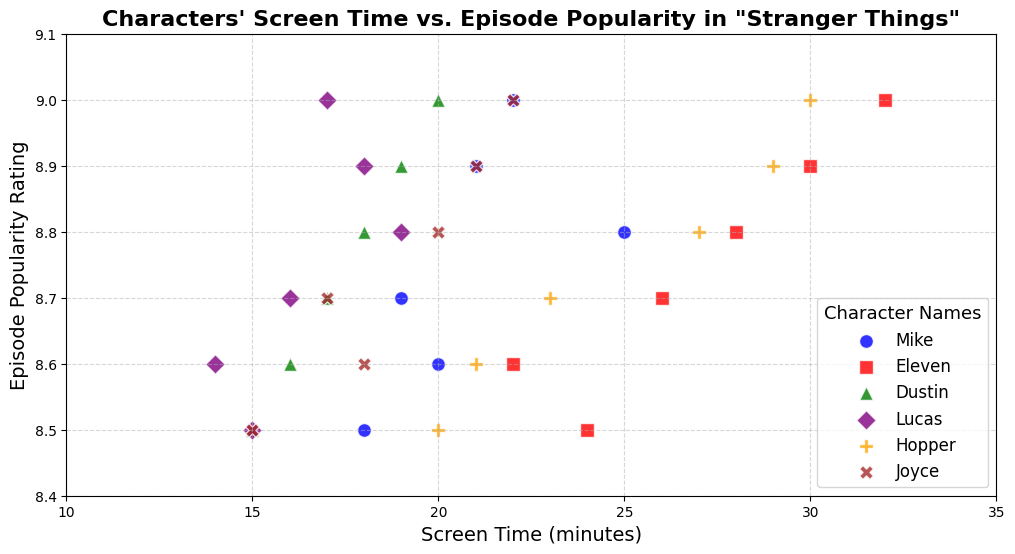Which character has the highest screen time in episode 1? By observing the plot, notice that the character with the highest screen time in episode 1 is represented by the red square marker. It corresponds to Eleven with a screen time of 24 minutes.
Answer: Eleven Between Dustin and Lucas, who has more screen time in episode 4? For episode 4, compare the green triangle marker (Dustin) and the purple diamond marker (Lucas). Notice that Lucas has 19 minutes while Dustin has 18 minutes.
Answer: Lucas Is there an episode where all characters have the same screen time? Scan the plot for any episode where all markers line up vertically at the same screen time value but in different colors and shapes. There is no such episode where all characters have the same screen time.
Answer: No Which character's screen time increased the most from episode 5 to episode 6? Compare the screen times of each character between episodes 5 and 6 by observing how much each marker moves along the x-axis. Eleven’s screen time increased from 30 to 32 minutes, an increase of 2 minutes. This is the highest increase.
Answer: Eleven What is the average screen time of Hopper across all episodes shown in the plot? Calculate Hopper's screen time for each episode: 20 + 21 + 23 + 27 + 29 + 30 = 150. There are 6 episodes, so the average is 150 / 6 = 25 minutes.
Answer: 25 Which character has a screen time closest to 20 minutes in episode 6? Identify the markers corresponding to episode 6 and find the closest to 20 minutes. Dustin’s green triangle marker at 20 minutes is closest.
Answer: Dustin How does episode popularity vary with screen time for Eleven? Observe the red square markers and trace their movement along both axes. As Eleven's screen time increases (24 to 32 minutes), episode popularity also increases from 8.5 to 9.0.
Answer: Increases Comparing Hopper and Joyce, who appears to have a more significant impact on episode popularity rating? Observe the orange pentagon markers and brown X markers. Hopper's episodes have slightly higher popularity ratings compared to Joyce’s episodes at similar screen times.
Answer: Hopper What is the total screen time for Dustin across all episodes? Sum Dustin's screen times across episodes: 15 + 16 + 17 + 18 + 19 + 20 = 105 minutes.
Answer: 105 Which character has the most occurrences of above-average screen time (assuming the average screen time for all characters is around approximately 20 minutes)? Count the number of occurrences where each character’s marker lies above the 20-minute mark. Eleven appears most frequently above 20 minutes.
Answer: Eleven 